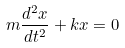<formula> <loc_0><loc_0><loc_500><loc_500>m \frac { d ^ { 2 } x } { d t ^ { 2 } } + k x = 0</formula> 